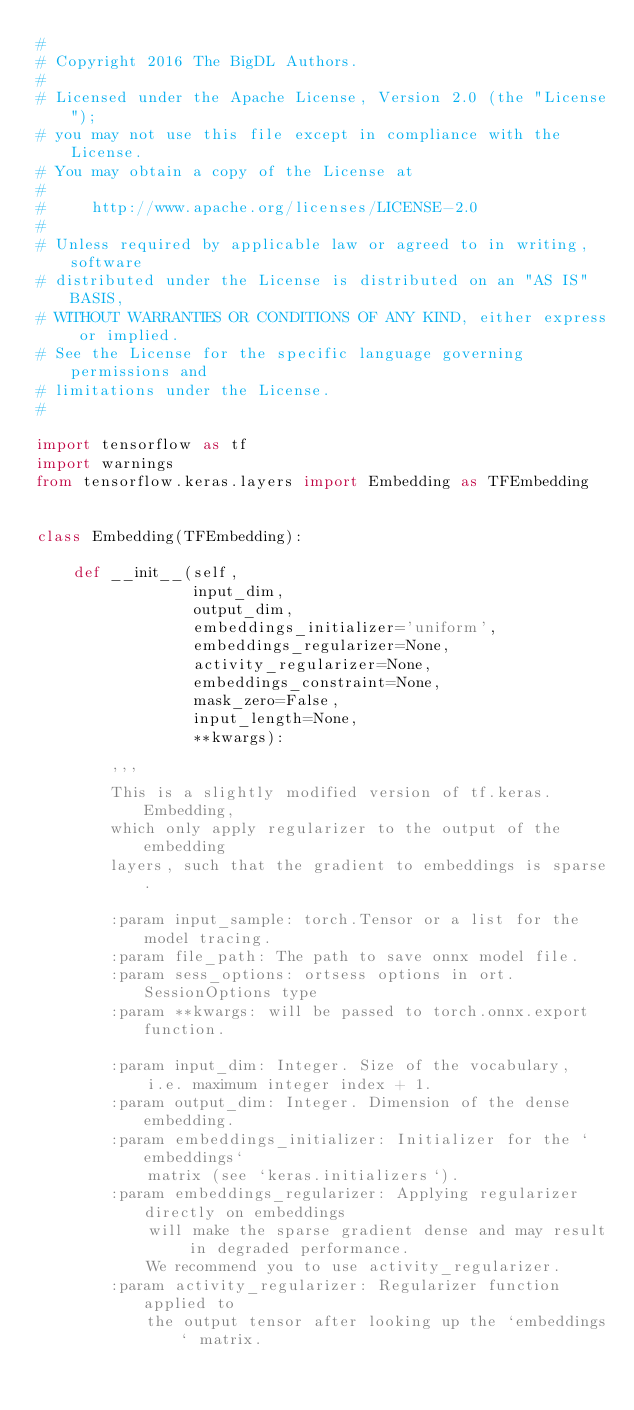Convert code to text. <code><loc_0><loc_0><loc_500><loc_500><_Python_>#
# Copyright 2016 The BigDL Authors.
#
# Licensed under the Apache License, Version 2.0 (the "License");
# you may not use this file except in compliance with the License.
# You may obtain a copy of the License at
#
#     http://www.apache.org/licenses/LICENSE-2.0
#
# Unless required by applicable law or agreed to in writing, software
# distributed under the License is distributed on an "AS IS" BASIS,
# WITHOUT WARRANTIES OR CONDITIONS OF ANY KIND, either express or implied.
# See the License for the specific language governing permissions and
# limitations under the License.
#

import tensorflow as tf
import warnings
from tensorflow.keras.layers import Embedding as TFEmbedding


class Embedding(TFEmbedding):

    def __init__(self,
                 input_dim,
                 output_dim,
                 embeddings_initializer='uniform',
                 embeddings_regularizer=None,
                 activity_regularizer=None,
                 embeddings_constraint=None,
                 mask_zero=False,
                 input_length=None,
                 **kwargs):

        '''
        This is a slightly modified version of tf.keras.Embedding,
        which only apply regularizer to the output of the embedding
        layers, such that the gradient to embeddings is sparse.

        :param input_sample: torch.Tensor or a list for the model tracing.
        :param file_path: The path to save onnx model file.
        :param sess_options: ortsess options in ort.SessionOptions type
        :param **kwargs: will be passed to torch.onnx.export function.

        :param input_dim: Integer. Size of the vocabulary,
            i.e. maximum integer index + 1.
        :param output_dim: Integer. Dimension of the dense embedding.
        :param embeddings_initializer: Initializer for the `embeddings`
            matrix (see `keras.initializers`).
        :param embeddings_regularizer: Applying regularizer directly on embeddings
            will make the sparse gradient dense and may result in degraded performance.
            We recommend you to use activity_regularizer.
        :param activity_regularizer: Regularizer function applied to
            the output tensor after looking up the `embeddings` matrix.</code> 